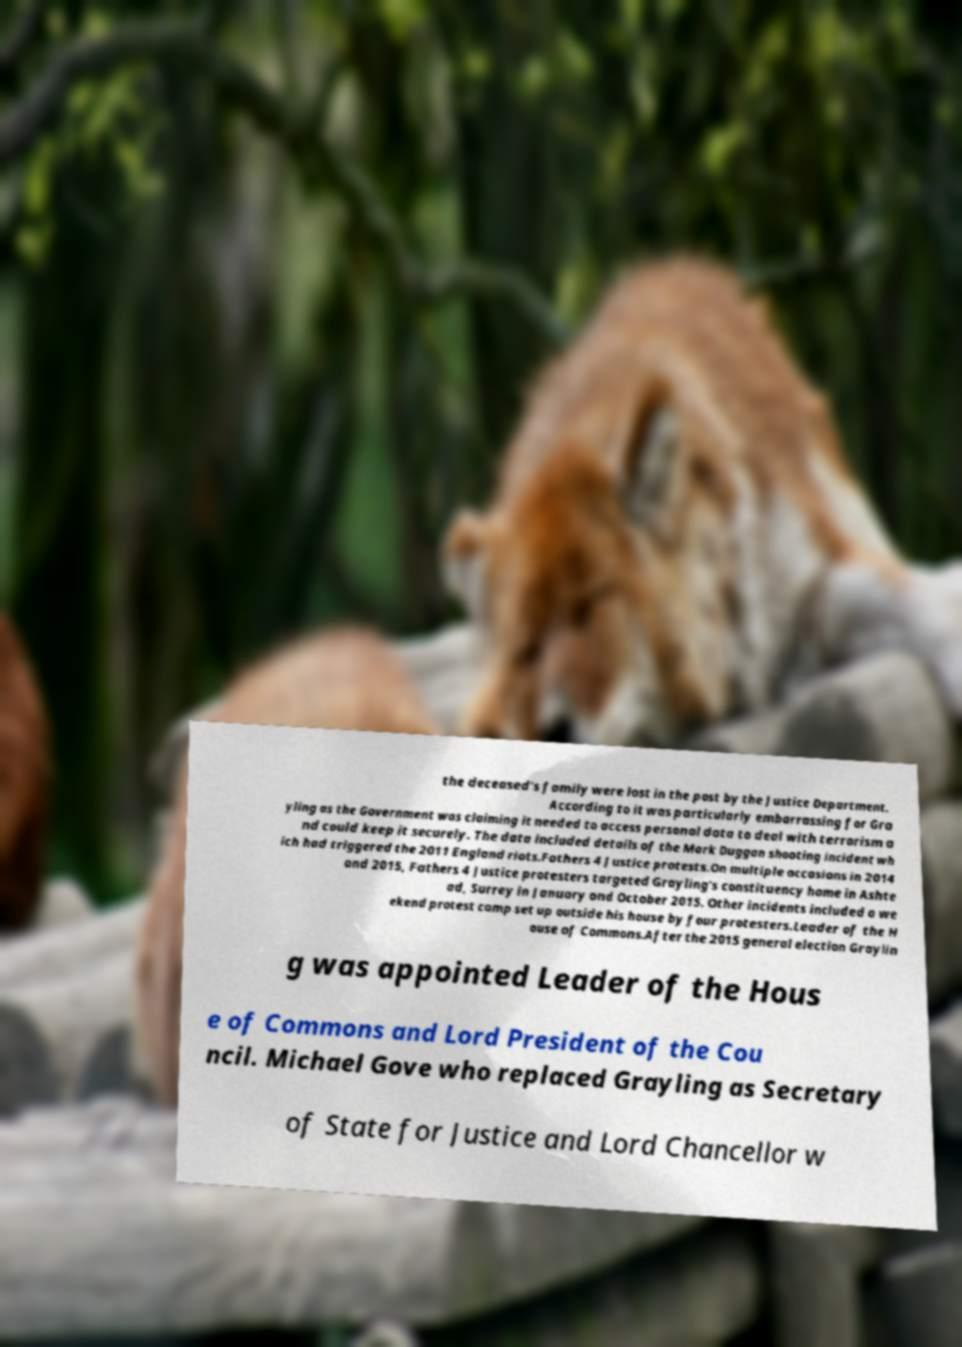For documentation purposes, I need the text within this image transcribed. Could you provide that? the deceased's family were lost in the post by the Justice Department. According to it was particularly embarrassing for Gra yling as the Government was claiming it needed to access personal data to deal with terrorism a nd could keep it securely. The data included details of the Mark Duggan shooting incident wh ich had triggered the 2011 England riots.Fathers 4 Justice protests.On multiple occasions in 2014 and 2015, Fathers 4 Justice protesters targeted Grayling's constituency home in Ashte ad, Surrey in January and October 2015. Other incidents included a we ekend protest camp set up outside his house by four protesters.Leader of the H ouse of Commons.After the 2015 general election Graylin g was appointed Leader of the Hous e of Commons and Lord President of the Cou ncil. Michael Gove who replaced Grayling as Secretary of State for Justice and Lord Chancellor w 